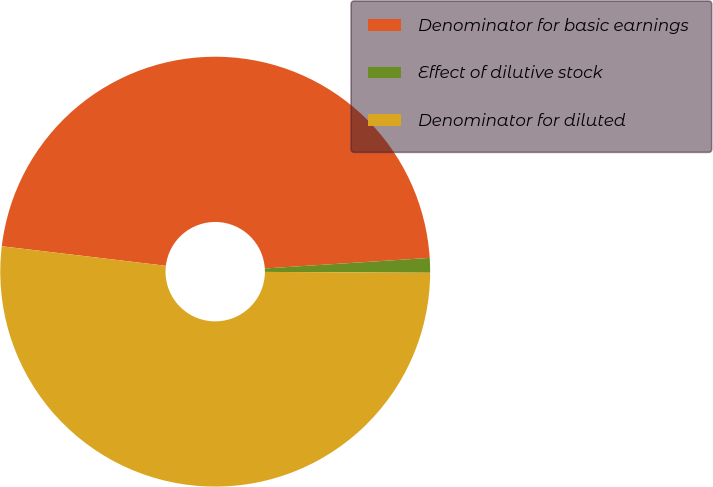<chart> <loc_0><loc_0><loc_500><loc_500><pie_chart><fcel>Denominator for basic earnings<fcel>Effect of dilutive stock<fcel>Denominator for diluted<nl><fcel>47.09%<fcel>1.1%<fcel>51.8%<nl></chart> 